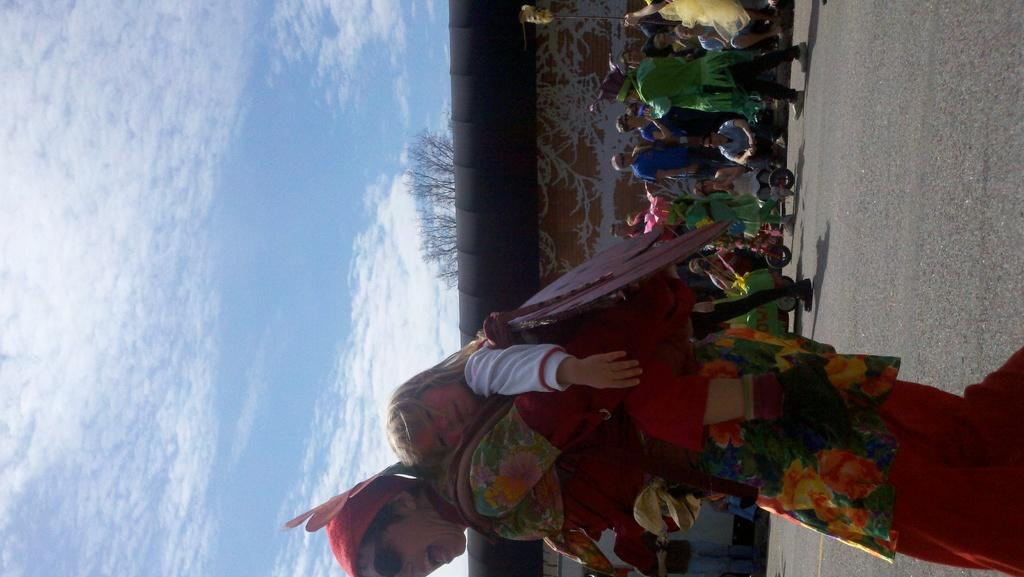What are the people in the image wearing? The people in the image are wearing different color dresses. Can you describe the person carrying a baby in the image? One person is carrying a baby in the image. What type of vehicles can be seen in the image? There are vehicles in the image. What kind of building is present in the image? There is a house in the image. What is the condition of the tree in the image? There is a dry tree in the image. What else is present in the image besides people and vehicles? There are objects in the image. What can be seen in the background of the image? The sky is visible in the image. What type of crate is being used to store the cushions in the image? There is no crate or cushions present in the image. How many whistles can be seen hanging on the dry tree in the image? There are no whistles present in the image; it only features a dry tree. 